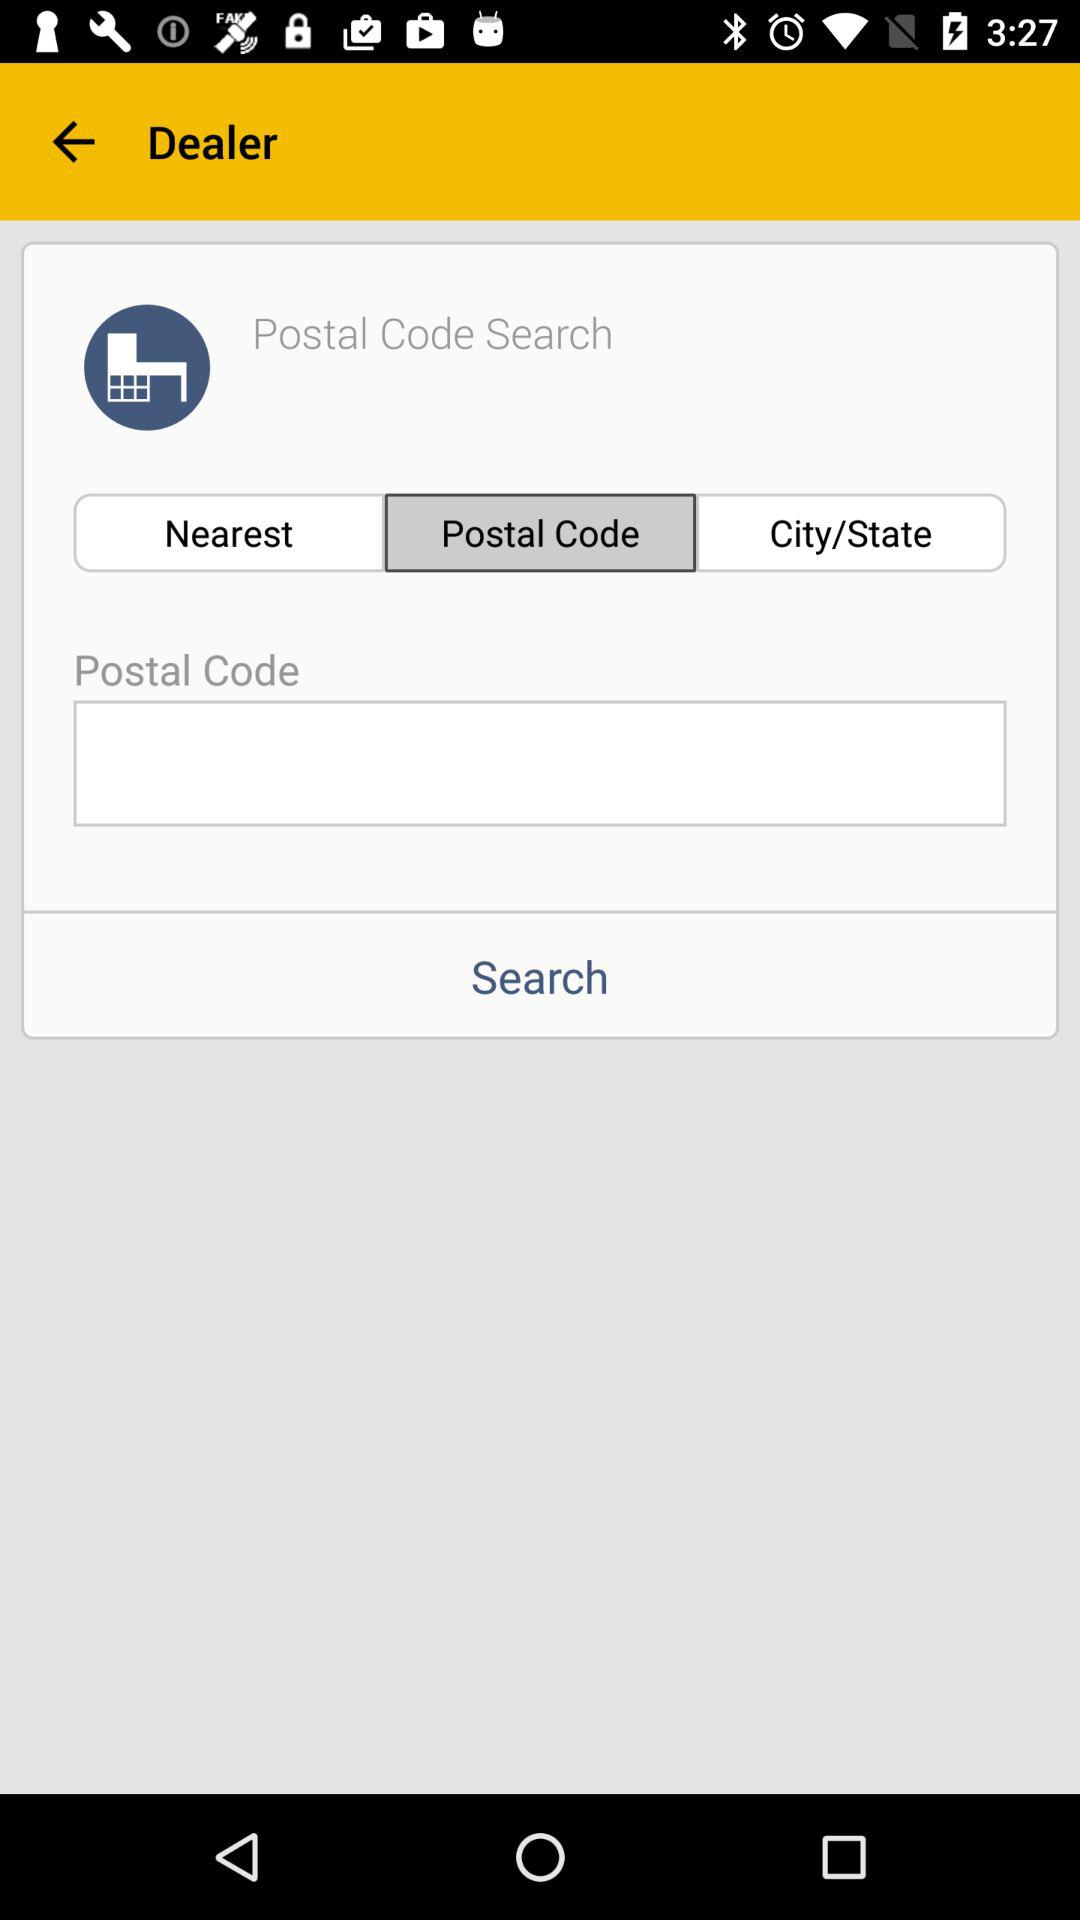How many options are there to choose from for locations?
Answer the question using a single word or phrase. 3 